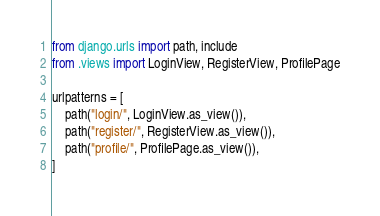<code> <loc_0><loc_0><loc_500><loc_500><_Python_>from django.urls import path, include
from .views import LoginView, RegisterView, ProfilePage

urlpatterns = [
    path("login/", LoginView.as_view()),
    path("register/", RegisterView.as_view()),
    path("profile/", ProfilePage.as_view()),
]
</code> 